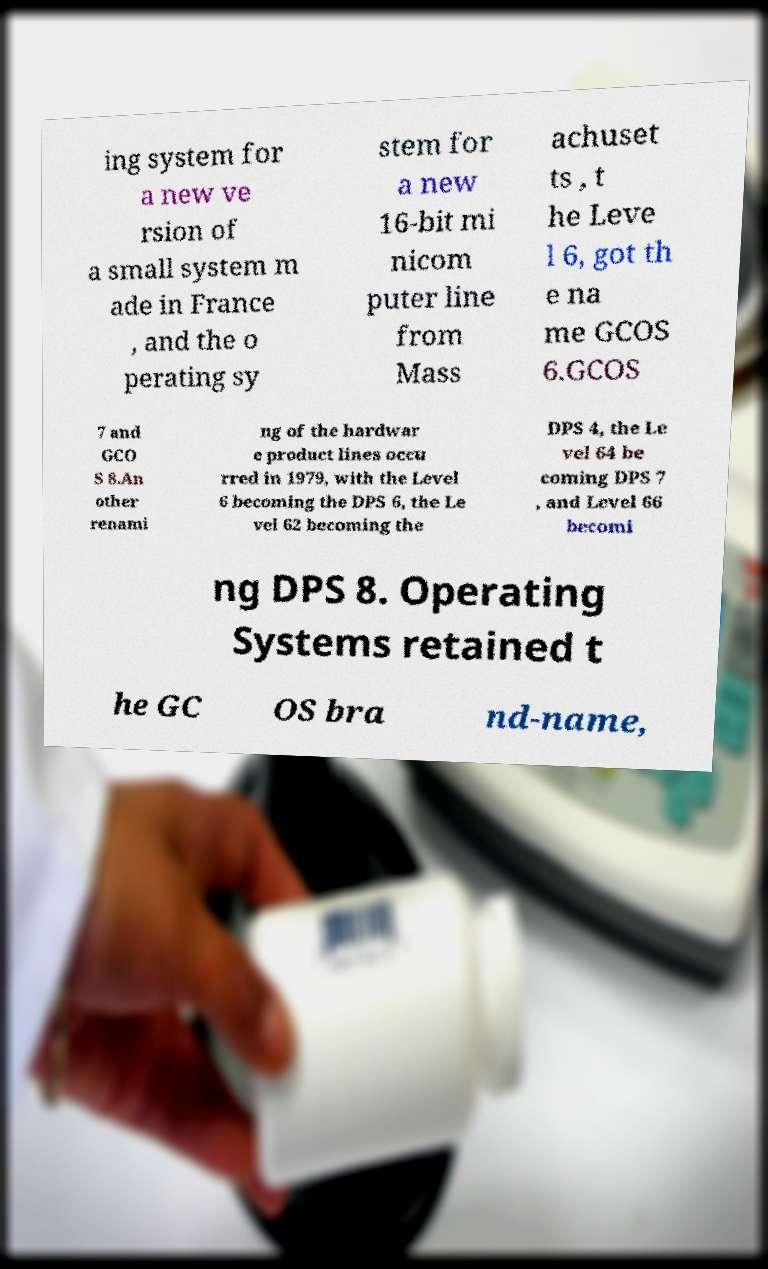Could you extract and type out the text from this image? ing system for a new ve rsion of a small system m ade in France , and the o perating sy stem for a new 16-bit mi nicom puter line from Mass achuset ts , t he Leve l 6, got th e na me GCOS 6.GCOS 7 and GCO S 8.An other renami ng of the hardwar e product lines occu rred in 1979, with the Level 6 becoming the DPS 6, the Le vel 62 becoming the DPS 4, the Le vel 64 be coming DPS 7 , and Level 66 becomi ng DPS 8. Operating Systems retained t he GC OS bra nd-name, 